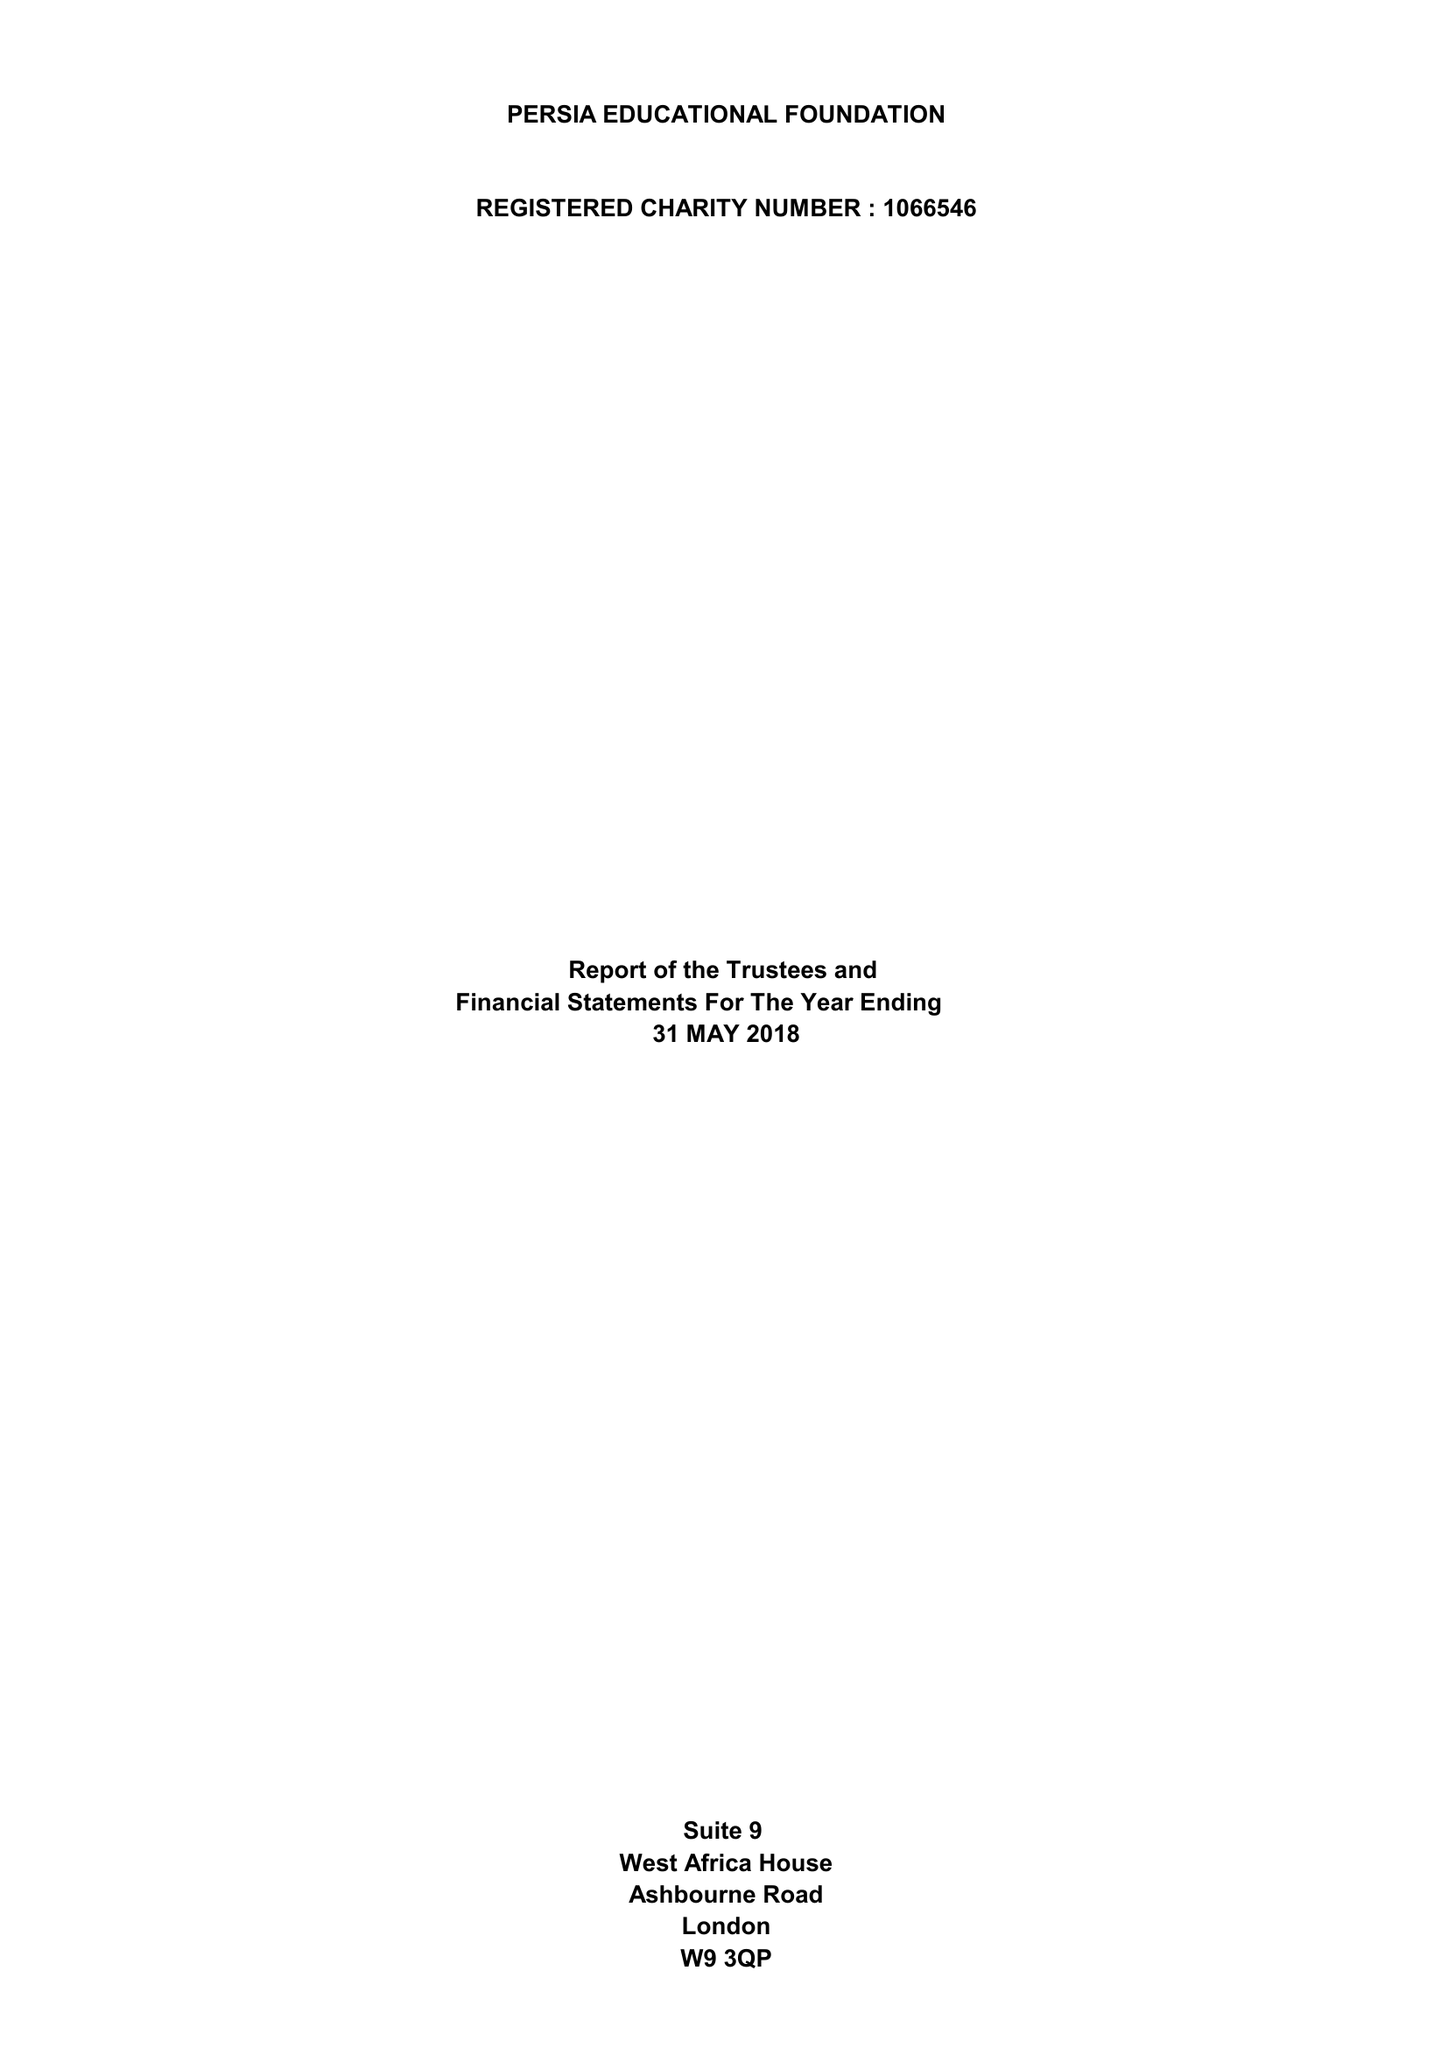What is the value for the charity_number?
Answer the question using a single word or phrase. 1066546 